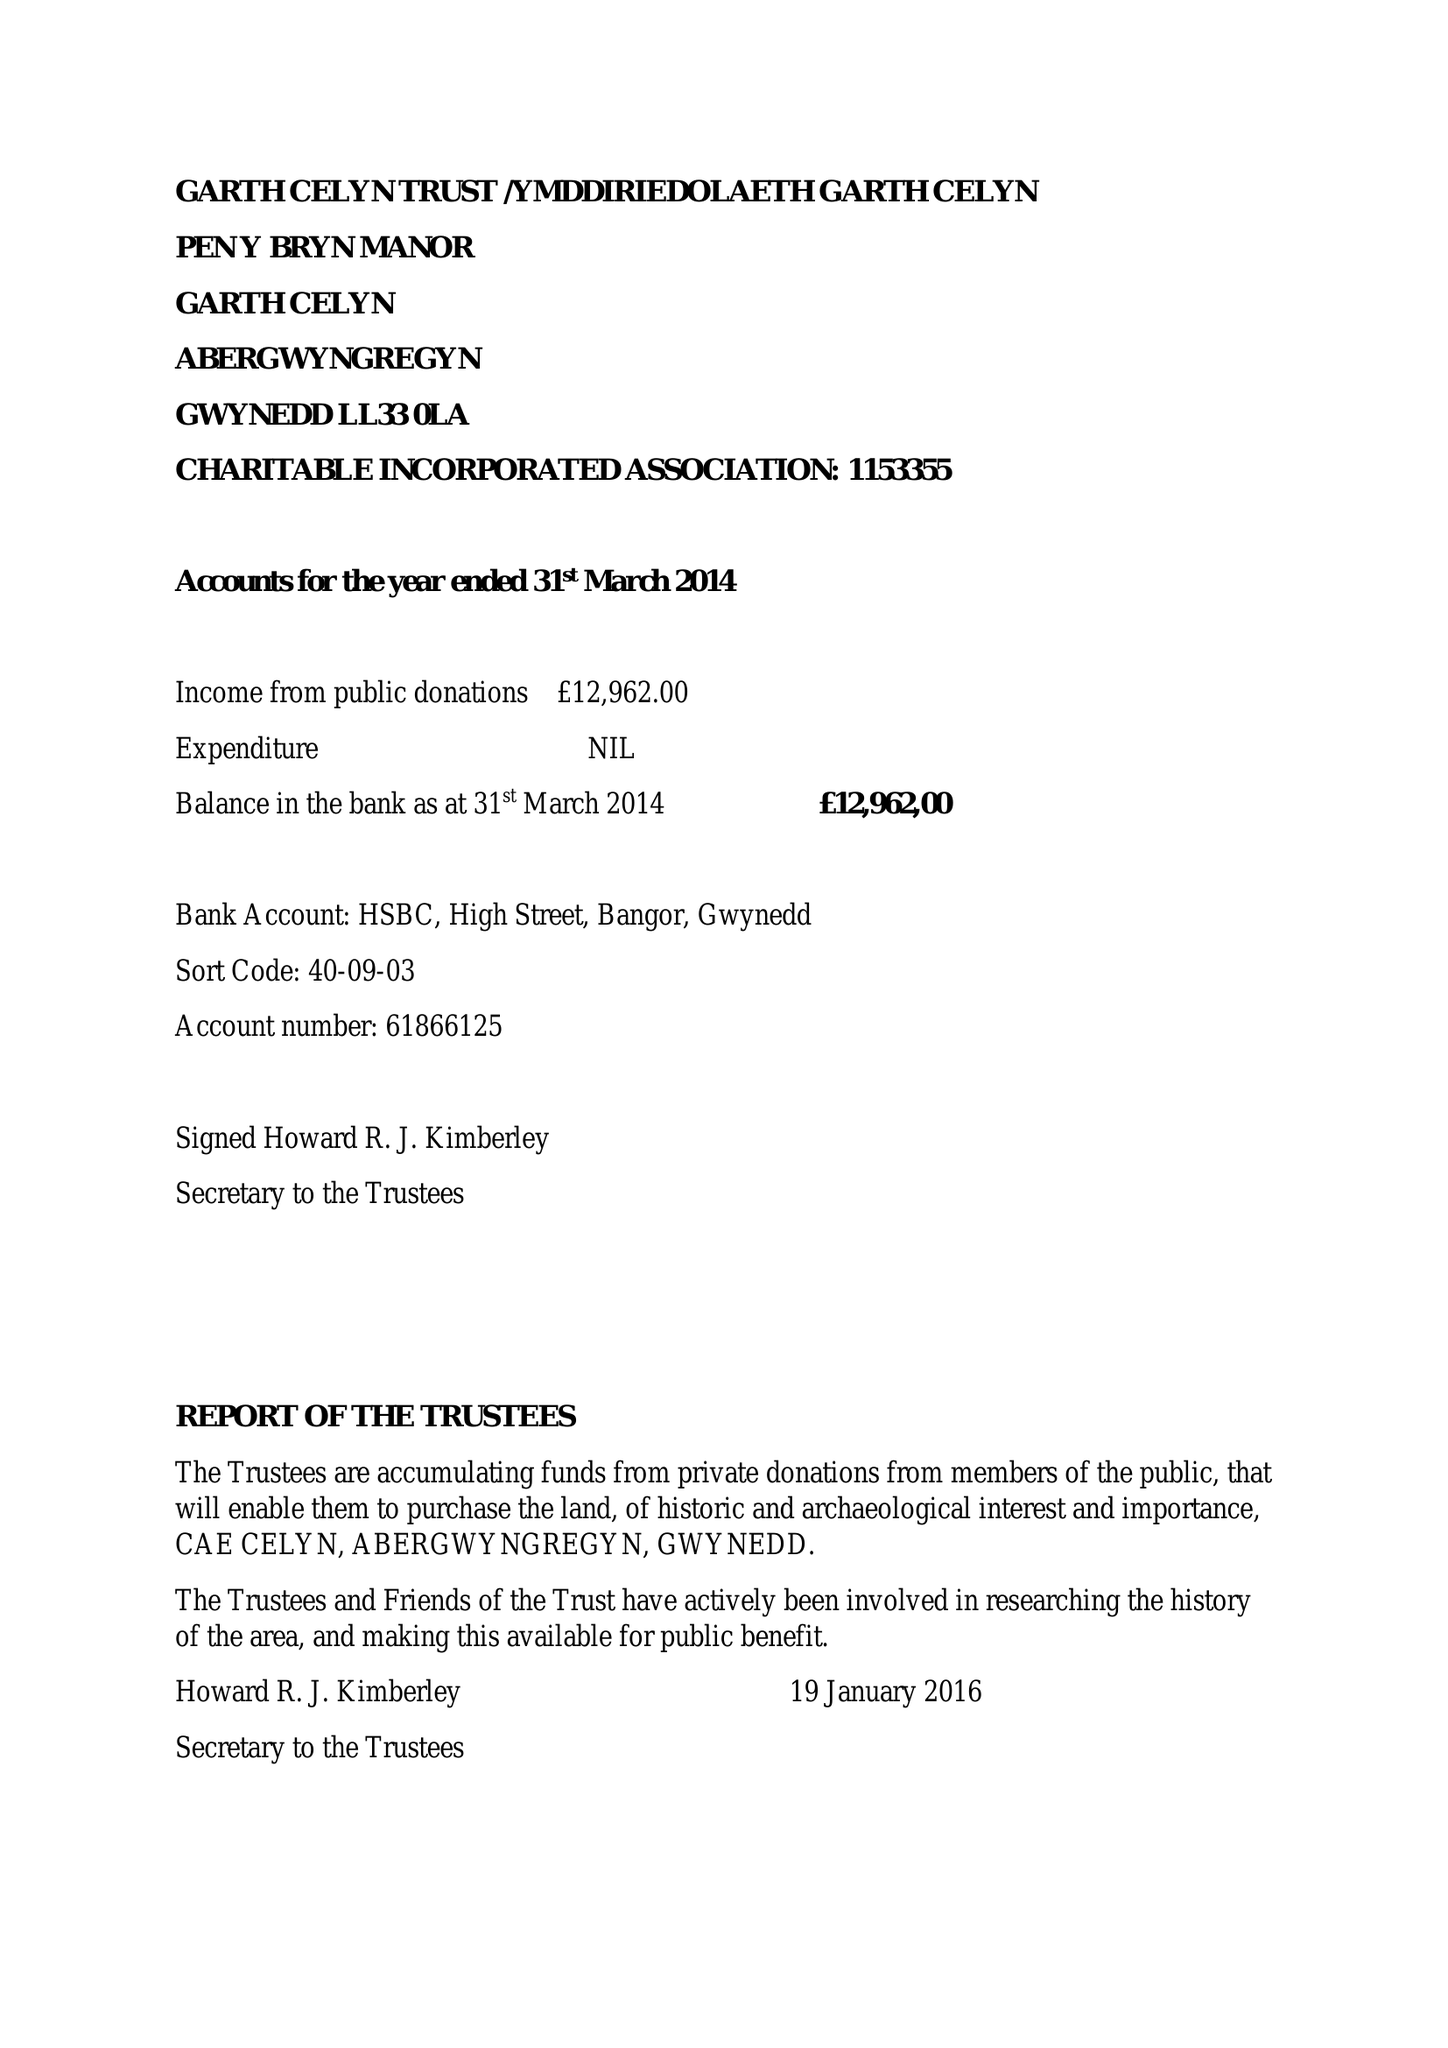What is the value for the charity_name?
Answer the question using a single word or phrase. Garth Celyn Trust 